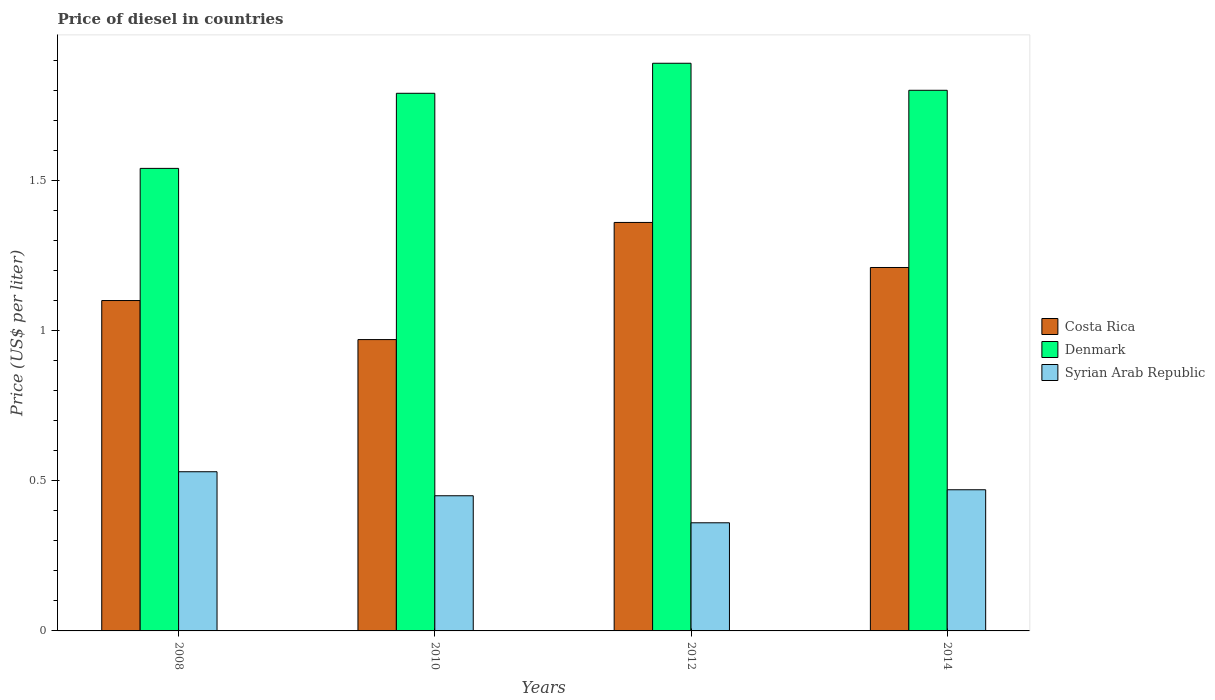How many different coloured bars are there?
Provide a short and direct response. 3. Across all years, what is the maximum price of diesel in Syrian Arab Republic?
Your response must be concise. 0.53. Across all years, what is the minimum price of diesel in Costa Rica?
Offer a very short reply. 0.97. In which year was the price of diesel in Syrian Arab Republic minimum?
Your response must be concise. 2012. What is the total price of diesel in Syrian Arab Republic in the graph?
Keep it short and to the point. 1.81. What is the difference between the price of diesel in Denmark in 2008 and that in 2014?
Make the answer very short. -0.26. What is the difference between the price of diesel in Costa Rica in 2008 and the price of diesel in Syrian Arab Republic in 2012?
Your response must be concise. 0.74. What is the average price of diesel in Denmark per year?
Your answer should be very brief. 1.75. In the year 2010, what is the difference between the price of diesel in Syrian Arab Republic and price of diesel in Costa Rica?
Make the answer very short. -0.52. What is the ratio of the price of diesel in Denmark in 2008 to that in 2010?
Keep it short and to the point. 0.86. Is the difference between the price of diesel in Syrian Arab Republic in 2008 and 2010 greater than the difference between the price of diesel in Costa Rica in 2008 and 2010?
Your answer should be very brief. No. What is the difference between the highest and the second highest price of diesel in Denmark?
Keep it short and to the point. 0.09. What is the difference between the highest and the lowest price of diesel in Costa Rica?
Your response must be concise. 0.39. Is the sum of the price of diesel in Costa Rica in 2008 and 2012 greater than the maximum price of diesel in Syrian Arab Republic across all years?
Your response must be concise. Yes. What does the 2nd bar from the left in 2014 represents?
Ensure brevity in your answer.  Denmark. What does the 1st bar from the right in 2010 represents?
Provide a short and direct response. Syrian Arab Republic. How many bars are there?
Give a very brief answer. 12. How many years are there in the graph?
Your response must be concise. 4. Does the graph contain any zero values?
Ensure brevity in your answer.  No. How many legend labels are there?
Offer a very short reply. 3. What is the title of the graph?
Your answer should be very brief. Price of diesel in countries. What is the label or title of the Y-axis?
Ensure brevity in your answer.  Price (US$ per liter). What is the Price (US$ per liter) of Denmark in 2008?
Provide a succinct answer. 1.54. What is the Price (US$ per liter) in Syrian Arab Republic in 2008?
Your response must be concise. 0.53. What is the Price (US$ per liter) of Costa Rica in 2010?
Ensure brevity in your answer.  0.97. What is the Price (US$ per liter) of Denmark in 2010?
Give a very brief answer. 1.79. What is the Price (US$ per liter) of Syrian Arab Republic in 2010?
Keep it short and to the point. 0.45. What is the Price (US$ per liter) in Costa Rica in 2012?
Your response must be concise. 1.36. What is the Price (US$ per liter) in Denmark in 2012?
Keep it short and to the point. 1.89. What is the Price (US$ per liter) in Syrian Arab Republic in 2012?
Your response must be concise. 0.36. What is the Price (US$ per liter) in Costa Rica in 2014?
Offer a terse response. 1.21. What is the Price (US$ per liter) of Syrian Arab Republic in 2014?
Keep it short and to the point. 0.47. Across all years, what is the maximum Price (US$ per liter) in Costa Rica?
Keep it short and to the point. 1.36. Across all years, what is the maximum Price (US$ per liter) of Denmark?
Make the answer very short. 1.89. Across all years, what is the maximum Price (US$ per liter) in Syrian Arab Republic?
Your response must be concise. 0.53. Across all years, what is the minimum Price (US$ per liter) of Costa Rica?
Keep it short and to the point. 0.97. Across all years, what is the minimum Price (US$ per liter) of Denmark?
Your answer should be very brief. 1.54. Across all years, what is the minimum Price (US$ per liter) of Syrian Arab Republic?
Offer a terse response. 0.36. What is the total Price (US$ per liter) in Costa Rica in the graph?
Make the answer very short. 4.64. What is the total Price (US$ per liter) in Denmark in the graph?
Your answer should be very brief. 7.02. What is the total Price (US$ per liter) in Syrian Arab Republic in the graph?
Offer a very short reply. 1.81. What is the difference between the Price (US$ per liter) in Costa Rica in 2008 and that in 2010?
Give a very brief answer. 0.13. What is the difference between the Price (US$ per liter) of Syrian Arab Republic in 2008 and that in 2010?
Provide a short and direct response. 0.08. What is the difference between the Price (US$ per liter) of Costa Rica in 2008 and that in 2012?
Keep it short and to the point. -0.26. What is the difference between the Price (US$ per liter) of Denmark in 2008 and that in 2012?
Offer a terse response. -0.35. What is the difference between the Price (US$ per liter) of Syrian Arab Republic in 2008 and that in 2012?
Give a very brief answer. 0.17. What is the difference between the Price (US$ per liter) of Costa Rica in 2008 and that in 2014?
Provide a succinct answer. -0.11. What is the difference between the Price (US$ per liter) in Denmark in 2008 and that in 2014?
Your response must be concise. -0.26. What is the difference between the Price (US$ per liter) of Costa Rica in 2010 and that in 2012?
Make the answer very short. -0.39. What is the difference between the Price (US$ per liter) in Denmark in 2010 and that in 2012?
Your response must be concise. -0.1. What is the difference between the Price (US$ per liter) in Syrian Arab Republic in 2010 and that in 2012?
Your answer should be compact. 0.09. What is the difference between the Price (US$ per liter) in Costa Rica in 2010 and that in 2014?
Give a very brief answer. -0.24. What is the difference between the Price (US$ per liter) of Denmark in 2010 and that in 2014?
Offer a very short reply. -0.01. What is the difference between the Price (US$ per liter) of Syrian Arab Republic in 2010 and that in 2014?
Your response must be concise. -0.02. What is the difference between the Price (US$ per liter) of Denmark in 2012 and that in 2014?
Keep it short and to the point. 0.09. What is the difference between the Price (US$ per liter) in Syrian Arab Republic in 2012 and that in 2014?
Provide a succinct answer. -0.11. What is the difference between the Price (US$ per liter) in Costa Rica in 2008 and the Price (US$ per liter) in Denmark in 2010?
Your answer should be very brief. -0.69. What is the difference between the Price (US$ per liter) in Costa Rica in 2008 and the Price (US$ per liter) in Syrian Arab Republic in 2010?
Your answer should be compact. 0.65. What is the difference between the Price (US$ per liter) in Denmark in 2008 and the Price (US$ per liter) in Syrian Arab Republic in 2010?
Keep it short and to the point. 1.09. What is the difference between the Price (US$ per liter) of Costa Rica in 2008 and the Price (US$ per liter) of Denmark in 2012?
Your answer should be very brief. -0.79. What is the difference between the Price (US$ per liter) of Costa Rica in 2008 and the Price (US$ per liter) of Syrian Arab Republic in 2012?
Your response must be concise. 0.74. What is the difference between the Price (US$ per liter) of Denmark in 2008 and the Price (US$ per liter) of Syrian Arab Republic in 2012?
Give a very brief answer. 1.18. What is the difference between the Price (US$ per liter) of Costa Rica in 2008 and the Price (US$ per liter) of Syrian Arab Republic in 2014?
Give a very brief answer. 0.63. What is the difference between the Price (US$ per liter) in Denmark in 2008 and the Price (US$ per liter) in Syrian Arab Republic in 2014?
Provide a short and direct response. 1.07. What is the difference between the Price (US$ per liter) of Costa Rica in 2010 and the Price (US$ per liter) of Denmark in 2012?
Your answer should be compact. -0.92. What is the difference between the Price (US$ per liter) of Costa Rica in 2010 and the Price (US$ per liter) of Syrian Arab Republic in 2012?
Provide a short and direct response. 0.61. What is the difference between the Price (US$ per liter) in Denmark in 2010 and the Price (US$ per liter) in Syrian Arab Republic in 2012?
Make the answer very short. 1.43. What is the difference between the Price (US$ per liter) in Costa Rica in 2010 and the Price (US$ per liter) in Denmark in 2014?
Offer a terse response. -0.83. What is the difference between the Price (US$ per liter) of Denmark in 2010 and the Price (US$ per liter) of Syrian Arab Republic in 2014?
Your response must be concise. 1.32. What is the difference between the Price (US$ per liter) of Costa Rica in 2012 and the Price (US$ per liter) of Denmark in 2014?
Ensure brevity in your answer.  -0.44. What is the difference between the Price (US$ per liter) of Costa Rica in 2012 and the Price (US$ per liter) of Syrian Arab Republic in 2014?
Your answer should be compact. 0.89. What is the difference between the Price (US$ per liter) of Denmark in 2012 and the Price (US$ per liter) of Syrian Arab Republic in 2014?
Your answer should be compact. 1.42. What is the average Price (US$ per liter) in Costa Rica per year?
Your answer should be compact. 1.16. What is the average Price (US$ per liter) in Denmark per year?
Your response must be concise. 1.75. What is the average Price (US$ per liter) in Syrian Arab Republic per year?
Provide a succinct answer. 0.45. In the year 2008, what is the difference between the Price (US$ per liter) of Costa Rica and Price (US$ per liter) of Denmark?
Keep it short and to the point. -0.44. In the year 2008, what is the difference between the Price (US$ per liter) of Costa Rica and Price (US$ per liter) of Syrian Arab Republic?
Provide a succinct answer. 0.57. In the year 2010, what is the difference between the Price (US$ per liter) of Costa Rica and Price (US$ per liter) of Denmark?
Provide a succinct answer. -0.82. In the year 2010, what is the difference between the Price (US$ per liter) in Costa Rica and Price (US$ per liter) in Syrian Arab Republic?
Provide a succinct answer. 0.52. In the year 2010, what is the difference between the Price (US$ per liter) of Denmark and Price (US$ per liter) of Syrian Arab Republic?
Keep it short and to the point. 1.34. In the year 2012, what is the difference between the Price (US$ per liter) in Costa Rica and Price (US$ per liter) in Denmark?
Your answer should be compact. -0.53. In the year 2012, what is the difference between the Price (US$ per liter) in Costa Rica and Price (US$ per liter) in Syrian Arab Republic?
Ensure brevity in your answer.  1. In the year 2012, what is the difference between the Price (US$ per liter) in Denmark and Price (US$ per liter) in Syrian Arab Republic?
Your answer should be compact. 1.53. In the year 2014, what is the difference between the Price (US$ per liter) in Costa Rica and Price (US$ per liter) in Denmark?
Make the answer very short. -0.59. In the year 2014, what is the difference between the Price (US$ per liter) in Costa Rica and Price (US$ per liter) in Syrian Arab Republic?
Provide a succinct answer. 0.74. In the year 2014, what is the difference between the Price (US$ per liter) of Denmark and Price (US$ per liter) of Syrian Arab Republic?
Keep it short and to the point. 1.33. What is the ratio of the Price (US$ per liter) of Costa Rica in 2008 to that in 2010?
Your answer should be very brief. 1.13. What is the ratio of the Price (US$ per liter) in Denmark in 2008 to that in 2010?
Provide a short and direct response. 0.86. What is the ratio of the Price (US$ per liter) in Syrian Arab Republic in 2008 to that in 2010?
Your answer should be compact. 1.18. What is the ratio of the Price (US$ per liter) of Costa Rica in 2008 to that in 2012?
Offer a terse response. 0.81. What is the ratio of the Price (US$ per liter) of Denmark in 2008 to that in 2012?
Your answer should be very brief. 0.81. What is the ratio of the Price (US$ per liter) in Syrian Arab Republic in 2008 to that in 2012?
Make the answer very short. 1.47. What is the ratio of the Price (US$ per liter) in Denmark in 2008 to that in 2014?
Ensure brevity in your answer.  0.86. What is the ratio of the Price (US$ per liter) of Syrian Arab Republic in 2008 to that in 2014?
Make the answer very short. 1.13. What is the ratio of the Price (US$ per liter) of Costa Rica in 2010 to that in 2012?
Make the answer very short. 0.71. What is the ratio of the Price (US$ per liter) in Denmark in 2010 to that in 2012?
Provide a succinct answer. 0.95. What is the ratio of the Price (US$ per liter) of Costa Rica in 2010 to that in 2014?
Ensure brevity in your answer.  0.8. What is the ratio of the Price (US$ per liter) in Syrian Arab Republic in 2010 to that in 2014?
Your response must be concise. 0.96. What is the ratio of the Price (US$ per liter) of Costa Rica in 2012 to that in 2014?
Your answer should be compact. 1.12. What is the ratio of the Price (US$ per liter) in Denmark in 2012 to that in 2014?
Your answer should be compact. 1.05. What is the ratio of the Price (US$ per liter) of Syrian Arab Republic in 2012 to that in 2014?
Your response must be concise. 0.77. What is the difference between the highest and the second highest Price (US$ per liter) in Costa Rica?
Offer a very short reply. 0.15. What is the difference between the highest and the second highest Price (US$ per liter) in Denmark?
Offer a terse response. 0.09. What is the difference between the highest and the second highest Price (US$ per liter) in Syrian Arab Republic?
Make the answer very short. 0.06. What is the difference between the highest and the lowest Price (US$ per liter) in Costa Rica?
Your answer should be very brief. 0.39. What is the difference between the highest and the lowest Price (US$ per liter) of Syrian Arab Republic?
Your response must be concise. 0.17. 